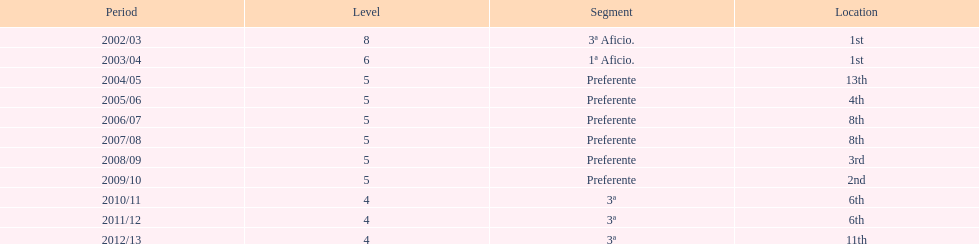In what year was the team's ranking identical to their 2010/11 standing? 2011/12. 